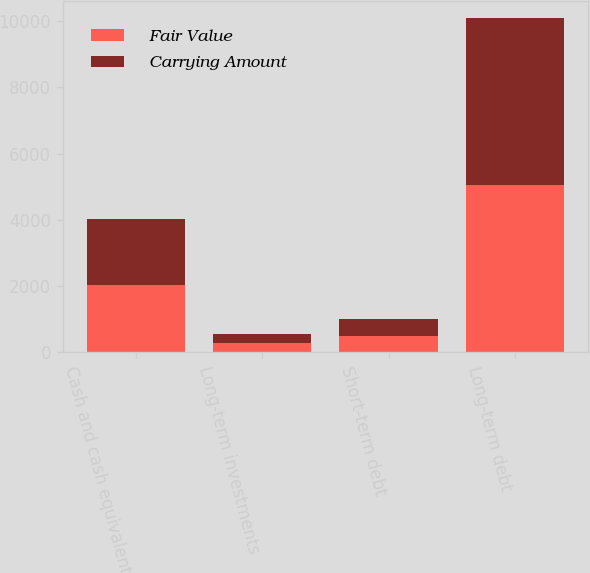Convert chart. <chart><loc_0><loc_0><loc_500><loc_500><stacked_bar_chart><ecel><fcel>Cash and cash equivalents<fcel>Long-term investments<fcel>Short-term debt<fcel>Long-term debt<nl><fcel>Fair Value<fcel>2020<fcel>277<fcel>498<fcel>5044<nl><fcel>Carrying Amount<fcel>2020<fcel>277<fcel>498<fcel>5062<nl></chart> 